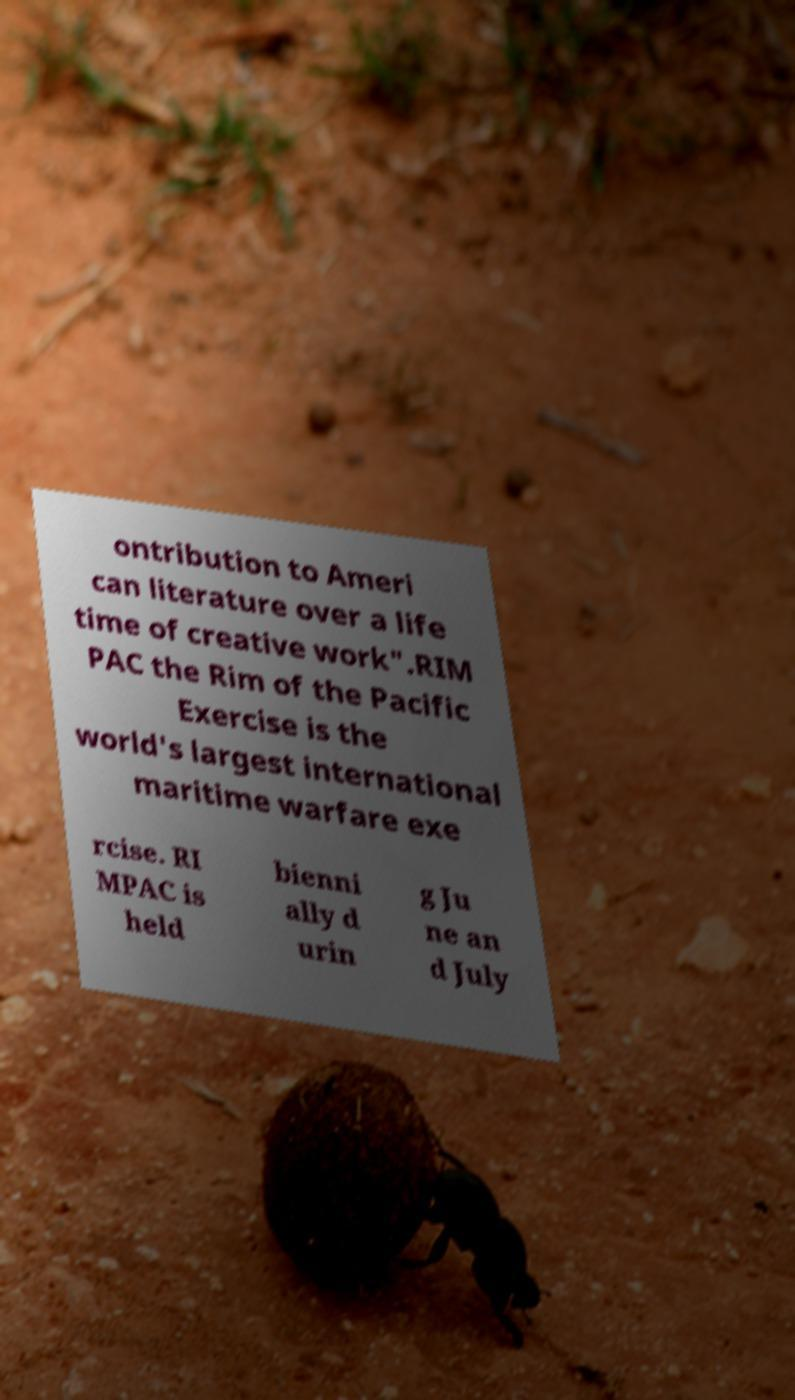Can you read and provide the text displayed in the image?This photo seems to have some interesting text. Can you extract and type it out for me? ontribution to Ameri can literature over a life time of creative work".RIM PAC the Rim of the Pacific Exercise is the world's largest international maritime warfare exe rcise. RI MPAC is held bienni ally d urin g Ju ne an d July 